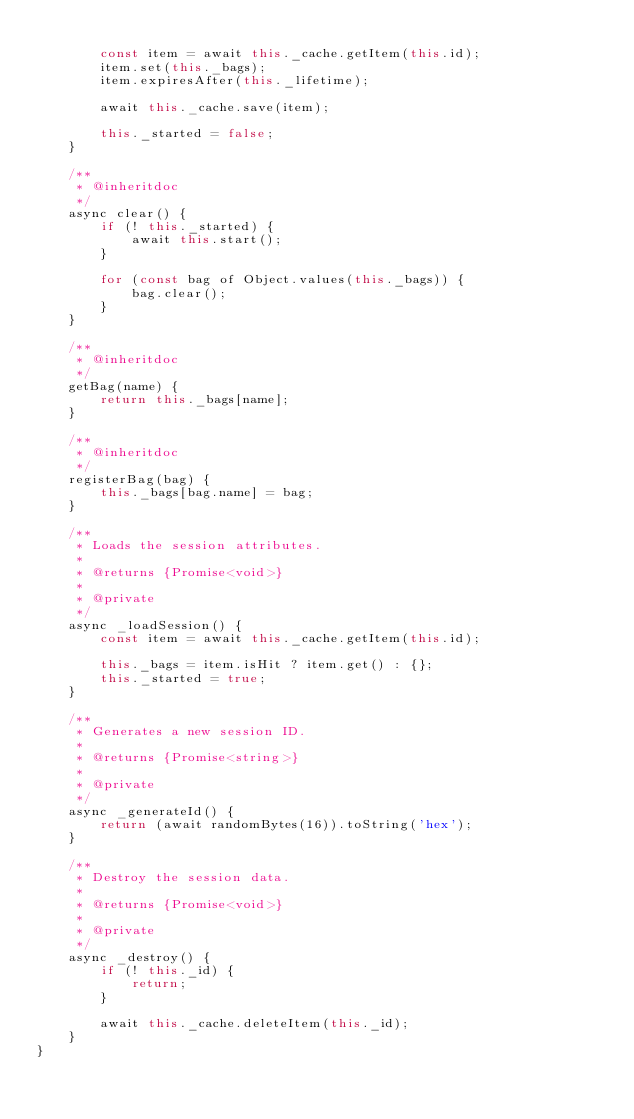Convert code to text. <code><loc_0><loc_0><loc_500><loc_500><_JavaScript_>
        const item = await this._cache.getItem(this.id);
        item.set(this._bags);
        item.expiresAfter(this._lifetime);

        await this._cache.save(item);

        this._started = false;
    }

    /**
     * @inheritdoc
     */
    async clear() {
        if (! this._started) {
            await this.start();
        }

        for (const bag of Object.values(this._bags)) {
            bag.clear();
        }
    }

    /**
     * @inheritdoc
     */
    getBag(name) {
        return this._bags[name];
    }

    /**
     * @inheritdoc
     */
    registerBag(bag) {
        this._bags[bag.name] = bag;
    }

    /**
     * Loads the session attributes.
     *
     * @returns {Promise<void>}
     *
     * @private
     */
    async _loadSession() {
        const item = await this._cache.getItem(this.id);

        this._bags = item.isHit ? item.get() : {};
        this._started = true;
    }

    /**
     * Generates a new session ID.
     *
     * @returns {Promise<string>}
     *
     * @private
     */
    async _generateId() {
        return (await randomBytes(16)).toString('hex');
    }

    /**
     * Destroy the session data.
     *
     * @returns {Promise<void>}
     *
     * @private
     */
    async _destroy() {
        if (! this._id) {
            return;
        }

        await this._cache.deleteItem(this._id);
    }
}
</code> 